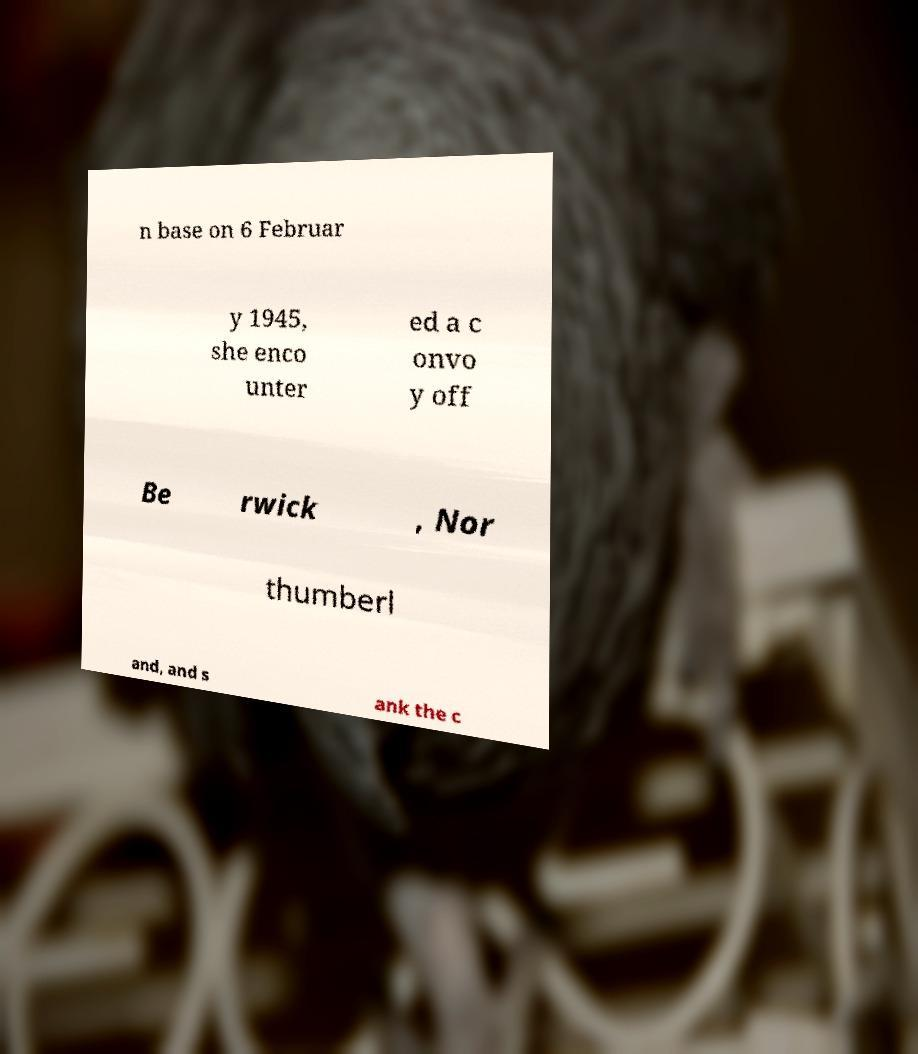There's text embedded in this image that I need extracted. Can you transcribe it verbatim? n base on 6 Februar y 1945, she enco unter ed a c onvo y off Be rwick , Nor thumberl and, and s ank the c 